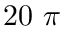<formula> <loc_0><loc_0><loc_500><loc_500>2 0 \pi</formula> 